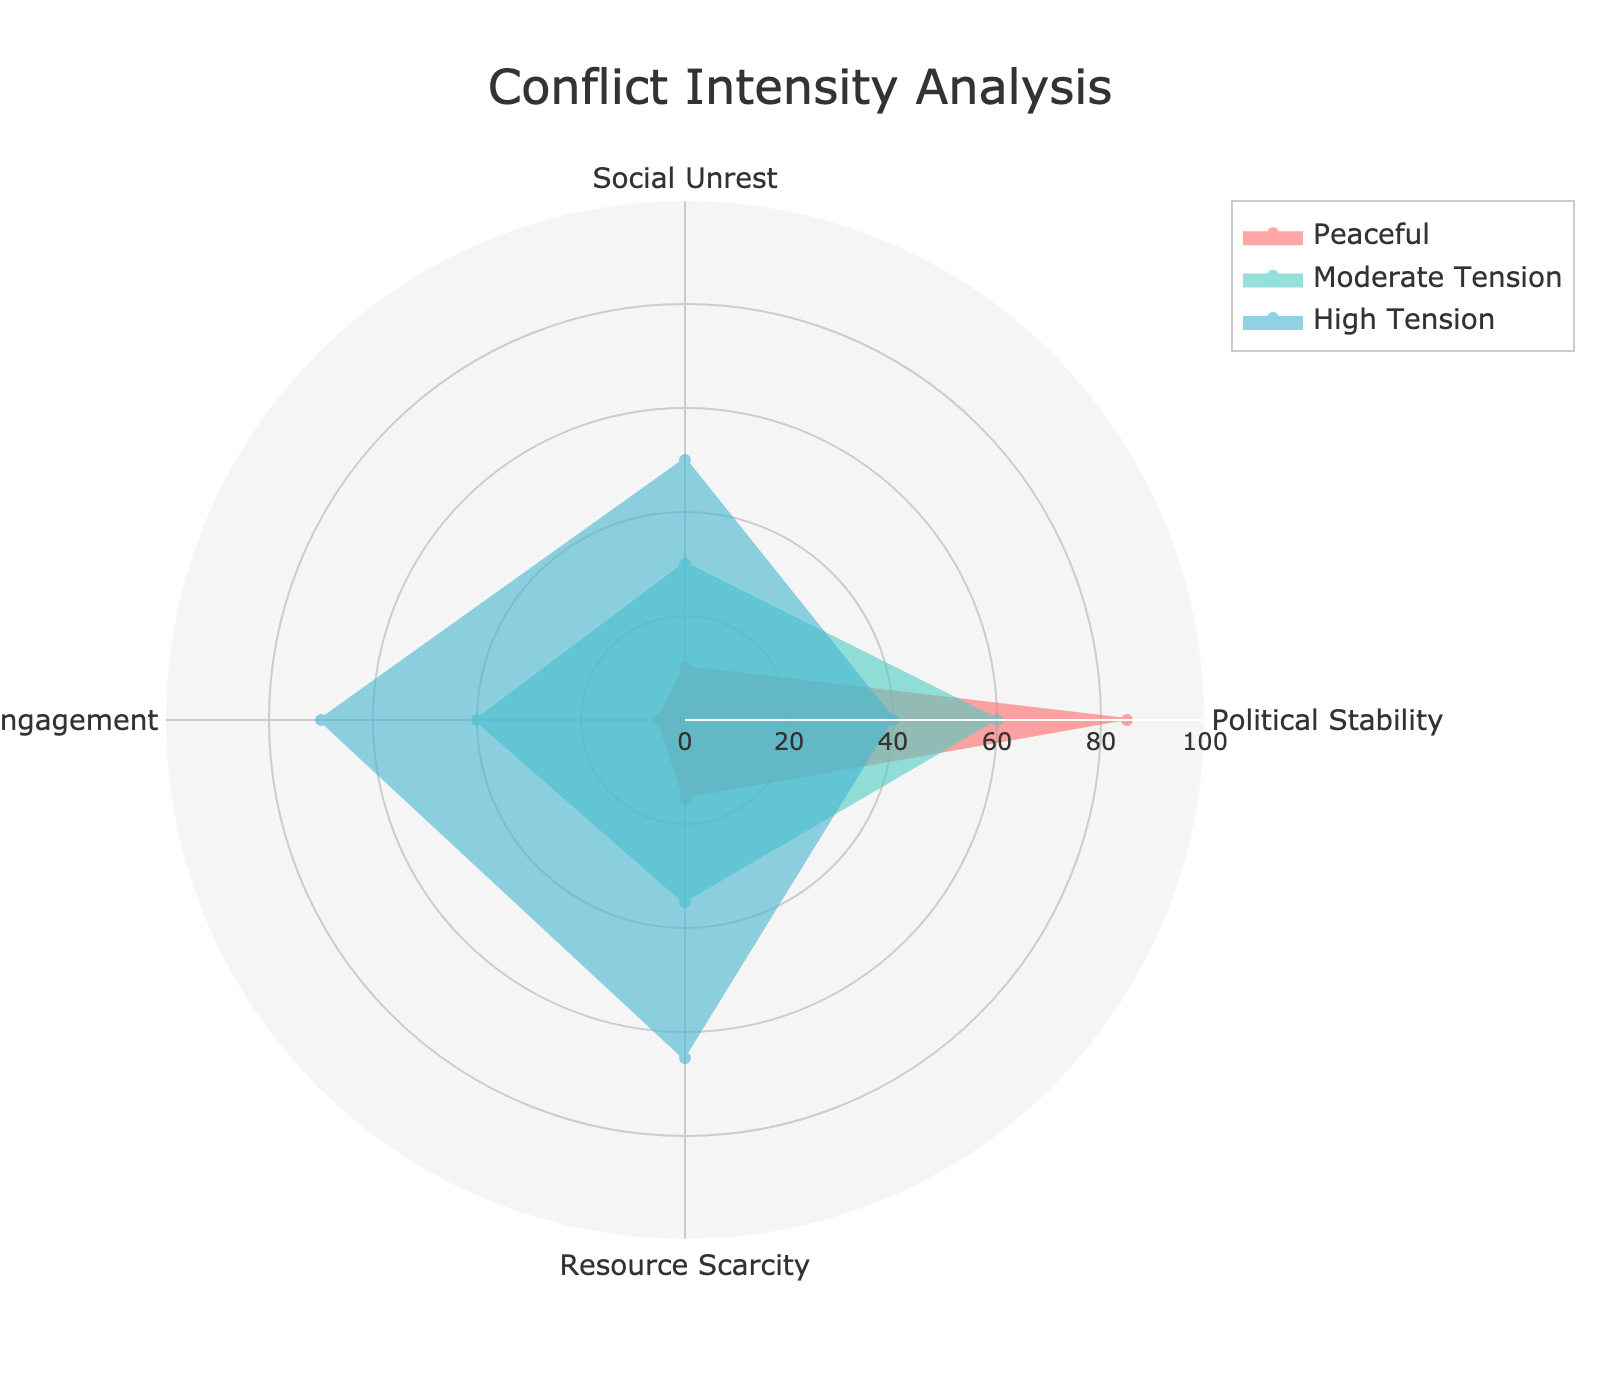What is the title of the radar chart? The title is located at the top center of the radar chart. It summarizes the purpose of the chart.
Answer: Conflict Intensity Analysis Which group has the highest value for Resource Scarcity? By locating the Resource Scarcity value on the radar chart, you can compare the values for each group. The group with the largest value will have the segment extending the furthest in this category.
Answer: High Tension What are the four categories measured in the radar chart? The categories are the axes extending from the center of the radar chart. They represent the dimensions along which the groups are compared.
Answer: Political Stability, Social Unrest, Military Engagement, Resource Scarcity Which group has the lowest values across almost all categories? By comparing all the categories for each group, identify the group with the smallest segments.
Answer: Peaceful How does the value of Social Unrest for Critical compare to Moderate Tension? Locate the Social Unrest values for both Critical and Moderate Tension groups. Check which one has a greater value by comparing the length of their segments.
Answer: Critical is higher What is the average value of Political Stability for all the displayed groups? Sum the Political Stability values for all groups displayed (85 + 60 + 40), then divide by the number of groups.
Answer: (85 + 60 + 40)/3 = 61.67 Which two groups are most similar in terms of Military Engagement? Compare the Military Engagement values for all groups to find the two closest values.
Answer: Moderate Tension and High Tension In which category do all the groups show the greatest variability in values? Compare the range of values for each category across the groups and identify the one with the widest range.
Answer: Military Engagement Order the groups from highest to lowest in Social Unrest. Compare the Social Unrest value of each group and list them in descending order.
Answer: Critical, High Tension, Moderate Tension, Peaceful If you combined the values of Resource Scarcity for Peaceful and Moderate Tension, what total would you get? Add the Resource Scarcity values for Peaceful and Moderate Tension.
Answer: 15 + 35 = 50 